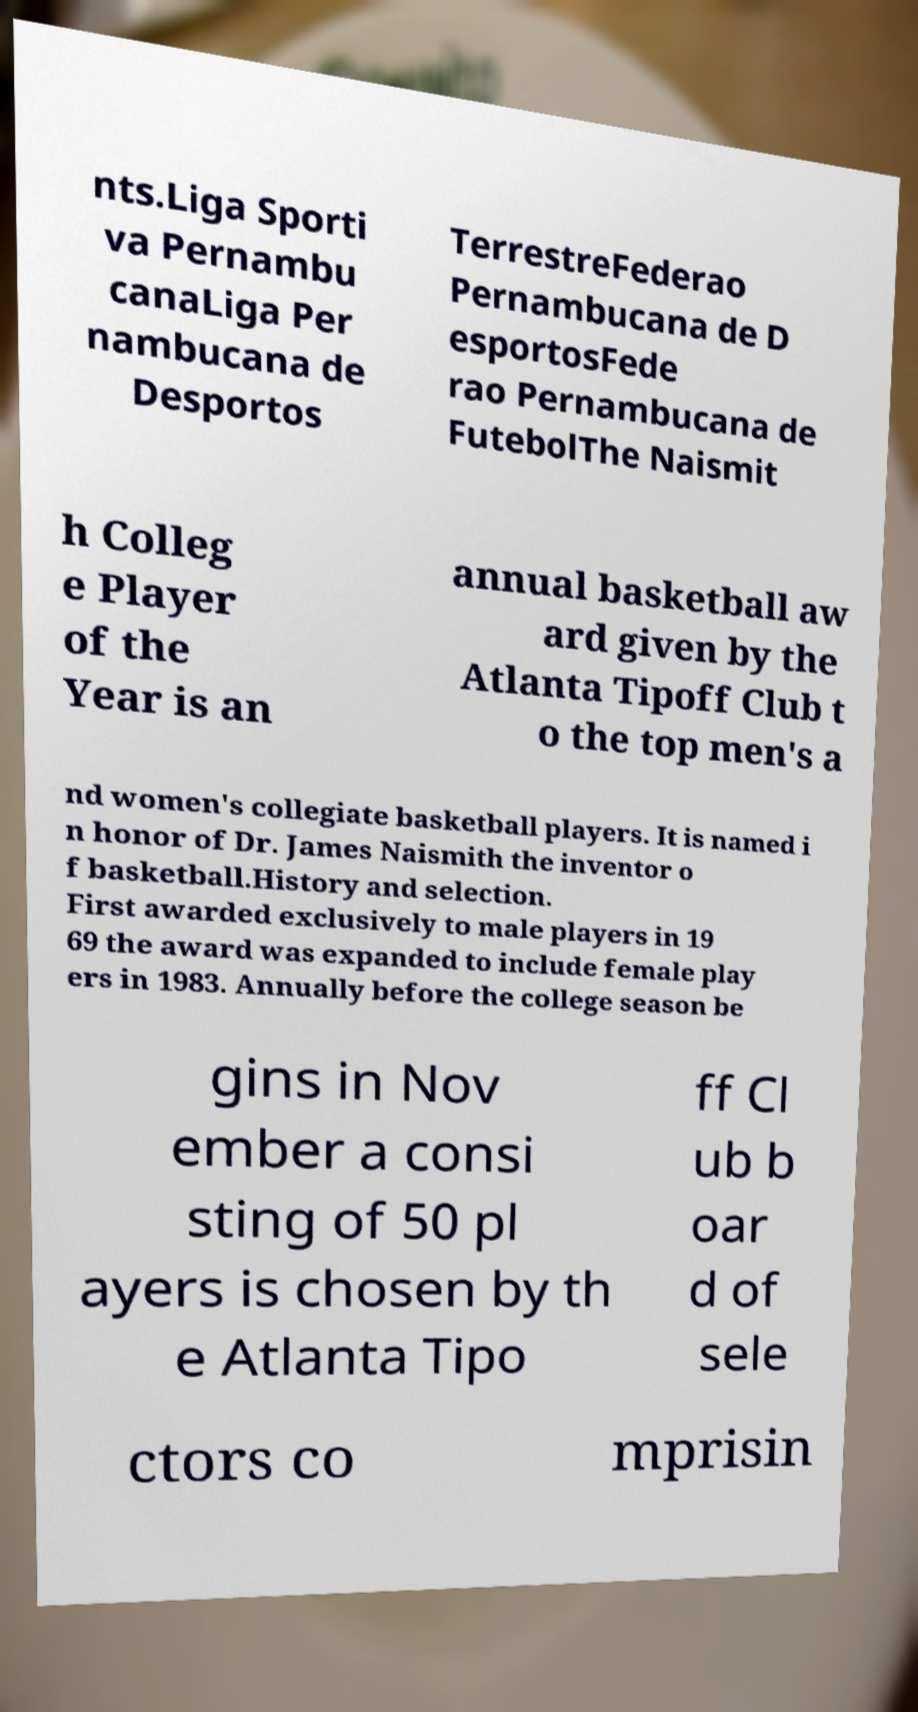What messages or text are displayed in this image? I need them in a readable, typed format. nts.Liga Sporti va Pernambu canaLiga Per nambucana de Desportos TerrestreFederao Pernambucana de D esportosFede rao Pernambucana de FutebolThe Naismit h Colleg e Player of the Year is an annual basketball aw ard given by the Atlanta Tipoff Club t o the top men's a nd women's collegiate basketball players. It is named i n honor of Dr. James Naismith the inventor o f basketball.History and selection. First awarded exclusively to male players in 19 69 the award was expanded to include female play ers in 1983. Annually before the college season be gins in Nov ember a consi sting of 50 pl ayers is chosen by th e Atlanta Tipo ff Cl ub b oar d of sele ctors co mprisin 